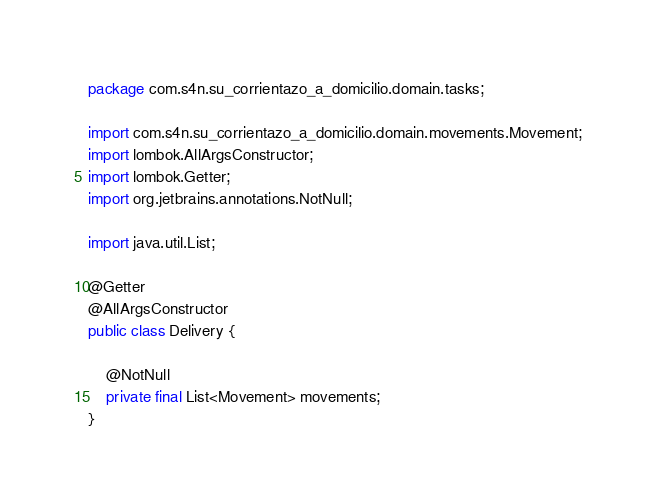Convert code to text. <code><loc_0><loc_0><loc_500><loc_500><_Java_>package com.s4n.su_corrientazo_a_domicilio.domain.tasks;

import com.s4n.su_corrientazo_a_domicilio.domain.movements.Movement;
import lombok.AllArgsConstructor;
import lombok.Getter;
import org.jetbrains.annotations.NotNull;

import java.util.List;

@Getter
@AllArgsConstructor
public class Delivery {

    @NotNull
    private final List<Movement> movements;
}
</code> 